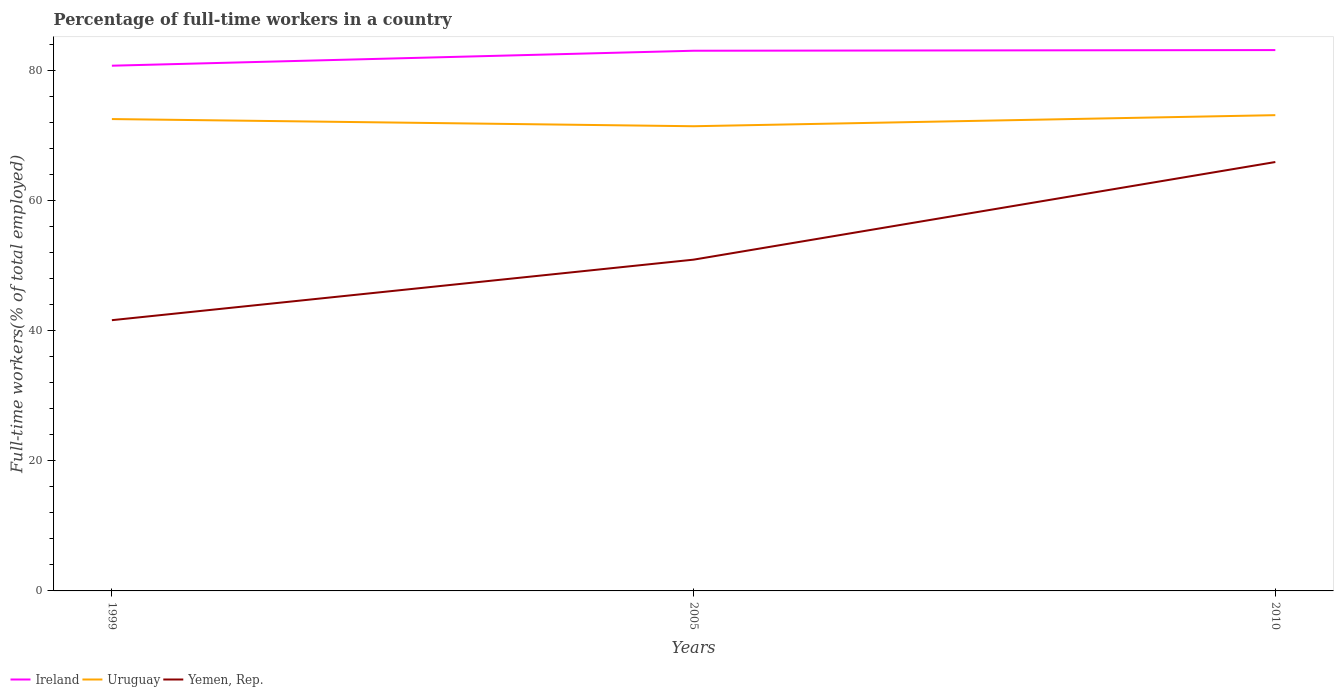Does the line corresponding to Ireland intersect with the line corresponding to Yemen, Rep.?
Make the answer very short. No. Is the number of lines equal to the number of legend labels?
Offer a very short reply. Yes. Across all years, what is the maximum percentage of full-time workers in Yemen, Rep.?
Ensure brevity in your answer.  41.6. In which year was the percentage of full-time workers in Uruguay maximum?
Your response must be concise. 2005. What is the total percentage of full-time workers in Uruguay in the graph?
Give a very brief answer. 1.1. What is the difference between the highest and the second highest percentage of full-time workers in Yemen, Rep.?
Offer a very short reply. 24.3. Is the percentage of full-time workers in Uruguay strictly greater than the percentage of full-time workers in Yemen, Rep. over the years?
Provide a short and direct response. No. How many years are there in the graph?
Your response must be concise. 3. What is the difference between two consecutive major ticks on the Y-axis?
Ensure brevity in your answer.  20. Does the graph contain any zero values?
Your response must be concise. No. Does the graph contain grids?
Provide a succinct answer. No. Where does the legend appear in the graph?
Keep it short and to the point. Bottom left. How are the legend labels stacked?
Your answer should be compact. Horizontal. What is the title of the graph?
Make the answer very short. Percentage of full-time workers in a country. What is the label or title of the Y-axis?
Keep it short and to the point. Full-time workers(% of total employed). What is the Full-time workers(% of total employed) in Ireland in 1999?
Provide a succinct answer. 80.7. What is the Full-time workers(% of total employed) of Uruguay in 1999?
Make the answer very short. 72.5. What is the Full-time workers(% of total employed) of Yemen, Rep. in 1999?
Your answer should be very brief. 41.6. What is the Full-time workers(% of total employed) in Ireland in 2005?
Give a very brief answer. 83. What is the Full-time workers(% of total employed) of Uruguay in 2005?
Your answer should be very brief. 71.4. What is the Full-time workers(% of total employed) of Yemen, Rep. in 2005?
Make the answer very short. 50.9. What is the Full-time workers(% of total employed) of Ireland in 2010?
Provide a succinct answer. 83.1. What is the Full-time workers(% of total employed) in Uruguay in 2010?
Keep it short and to the point. 73.1. What is the Full-time workers(% of total employed) of Yemen, Rep. in 2010?
Your answer should be very brief. 65.9. Across all years, what is the maximum Full-time workers(% of total employed) in Ireland?
Your answer should be compact. 83.1. Across all years, what is the maximum Full-time workers(% of total employed) of Uruguay?
Make the answer very short. 73.1. Across all years, what is the maximum Full-time workers(% of total employed) of Yemen, Rep.?
Give a very brief answer. 65.9. Across all years, what is the minimum Full-time workers(% of total employed) of Ireland?
Provide a short and direct response. 80.7. Across all years, what is the minimum Full-time workers(% of total employed) in Uruguay?
Provide a short and direct response. 71.4. Across all years, what is the minimum Full-time workers(% of total employed) in Yemen, Rep.?
Ensure brevity in your answer.  41.6. What is the total Full-time workers(% of total employed) in Ireland in the graph?
Offer a very short reply. 246.8. What is the total Full-time workers(% of total employed) in Uruguay in the graph?
Offer a terse response. 217. What is the total Full-time workers(% of total employed) of Yemen, Rep. in the graph?
Ensure brevity in your answer.  158.4. What is the difference between the Full-time workers(% of total employed) in Yemen, Rep. in 1999 and that in 2005?
Provide a short and direct response. -9.3. What is the difference between the Full-time workers(% of total employed) of Uruguay in 1999 and that in 2010?
Your response must be concise. -0.6. What is the difference between the Full-time workers(% of total employed) in Yemen, Rep. in 1999 and that in 2010?
Your answer should be very brief. -24.3. What is the difference between the Full-time workers(% of total employed) in Yemen, Rep. in 2005 and that in 2010?
Offer a terse response. -15. What is the difference between the Full-time workers(% of total employed) in Ireland in 1999 and the Full-time workers(% of total employed) in Yemen, Rep. in 2005?
Ensure brevity in your answer.  29.8. What is the difference between the Full-time workers(% of total employed) in Uruguay in 1999 and the Full-time workers(% of total employed) in Yemen, Rep. in 2005?
Ensure brevity in your answer.  21.6. What is the difference between the Full-time workers(% of total employed) in Ireland in 1999 and the Full-time workers(% of total employed) in Yemen, Rep. in 2010?
Ensure brevity in your answer.  14.8. What is the difference between the Full-time workers(% of total employed) in Ireland in 2005 and the Full-time workers(% of total employed) in Yemen, Rep. in 2010?
Offer a very short reply. 17.1. What is the average Full-time workers(% of total employed) in Ireland per year?
Make the answer very short. 82.27. What is the average Full-time workers(% of total employed) in Uruguay per year?
Your answer should be compact. 72.33. What is the average Full-time workers(% of total employed) in Yemen, Rep. per year?
Make the answer very short. 52.8. In the year 1999, what is the difference between the Full-time workers(% of total employed) in Ireland and Full-time workers(% of total employed) in Yemen, Rep.?
Give a very brief answer. 39.1. In the year 1999, what is the difference between the Full-time workers(% of total employed) of Uruguay and Full-time workers(% of total employed) of Yemen, Rep.?
Provide a succinct answer. 30.9. In the year 2005, what is the difference between the Full-time workers(% of total employed) in Ireland and Full-time workers(% of total employed) in Uruguay?
Your response must be concise. 11.6. In the year 2005, what is the difference between the Full-time workers(% of total employed) of Ireland and Full-time workers(% of total employed) of Yemen, Rep.?
Offer a terse response. 32.1. In the year 2005, what is the difference between the Full-time workers(% of total employed) of Uruguay and Full-time workers(% of total employed) of Yemen, Rep.?
Your answer should be very brief. 20.5. In the year 2010, what is the difference between the Full-time workers(% of total employed) of Ireland and Full-time workers(% of total employed) of Uruguay?
Make the answer very short. 10. In the year 2010, what is the difference between the Full-time workers(% of total employed) in Ireland and Full-time workers(% of total employed) in Yemen, Rep.?
Your answer should be very brief. 17.2. In the year 2010, what is the difference between the Full-time workers(% of total employed) of Uruguay and Full-time workers(% of total employed) of Yemen, Rep.?
Offer a terse response. 7.2. What is the ratio of the Full-time workers(% of total employed) in Ireland in 1999 to that in 2005?
Your answer should be very brief. 0.97. What is the ratio of the Full-time workers(% of total employed) in Uruguay in 1999 to that in 2005?
Provide a succinct answer. 1.02. What is the ratio of the Full-time workers(% of total employed) in Yemen, Rep. in 1999 to that in 2005?
Make the answer very short. 0.82. What is the ratio of the Full-time workers(% of total employed) in Ireland in 1999 to that in 2010?
Offer a very short reply. 0.97. What is the ratio of the Full-time workers(% of total employed) in Yemen, Rep. in 1999 to that in 2010?
Make the answer very short. 0.63. What is the ratio of the Full-time workers(% of total employed) of Uruguay in 2005 to that in 2010?
Ensure brevity in your answer.  0.98. What is the ratio of the Full-time workers(% of total employed) of Yemen, Rep. in 2005 to that in 2010?
Provide a short and direct response. 0.77. What is the difference between the highest and the second highest Full-time workers(% of total employed) in Ireland?
Give a very brief answer. 0.1. What is the difference between the highest and the second highest Full-time workers(% of total employed) of Uruguay?
Ensure brevity in your answer.  0.6. What is the difference between the highest and the second highest Full-time workers(% of total employed) in Yemen, Rep.?
Give a very brief answer. 15. What is the difference between the highest and the lowest Full-time workers(% of total employed) of Ireland?
Ensure brevity in your answer.  2.4. What is the difference between the highest and the lowest Full-time workers(% of total employed) in Uruguay?
Give a very brief answer. 1.7. What is the difference between the highest and the lowest Full-time workers(% of total employed) of Yemen, Rep.?
Keep it short and to the point. 24.3. 